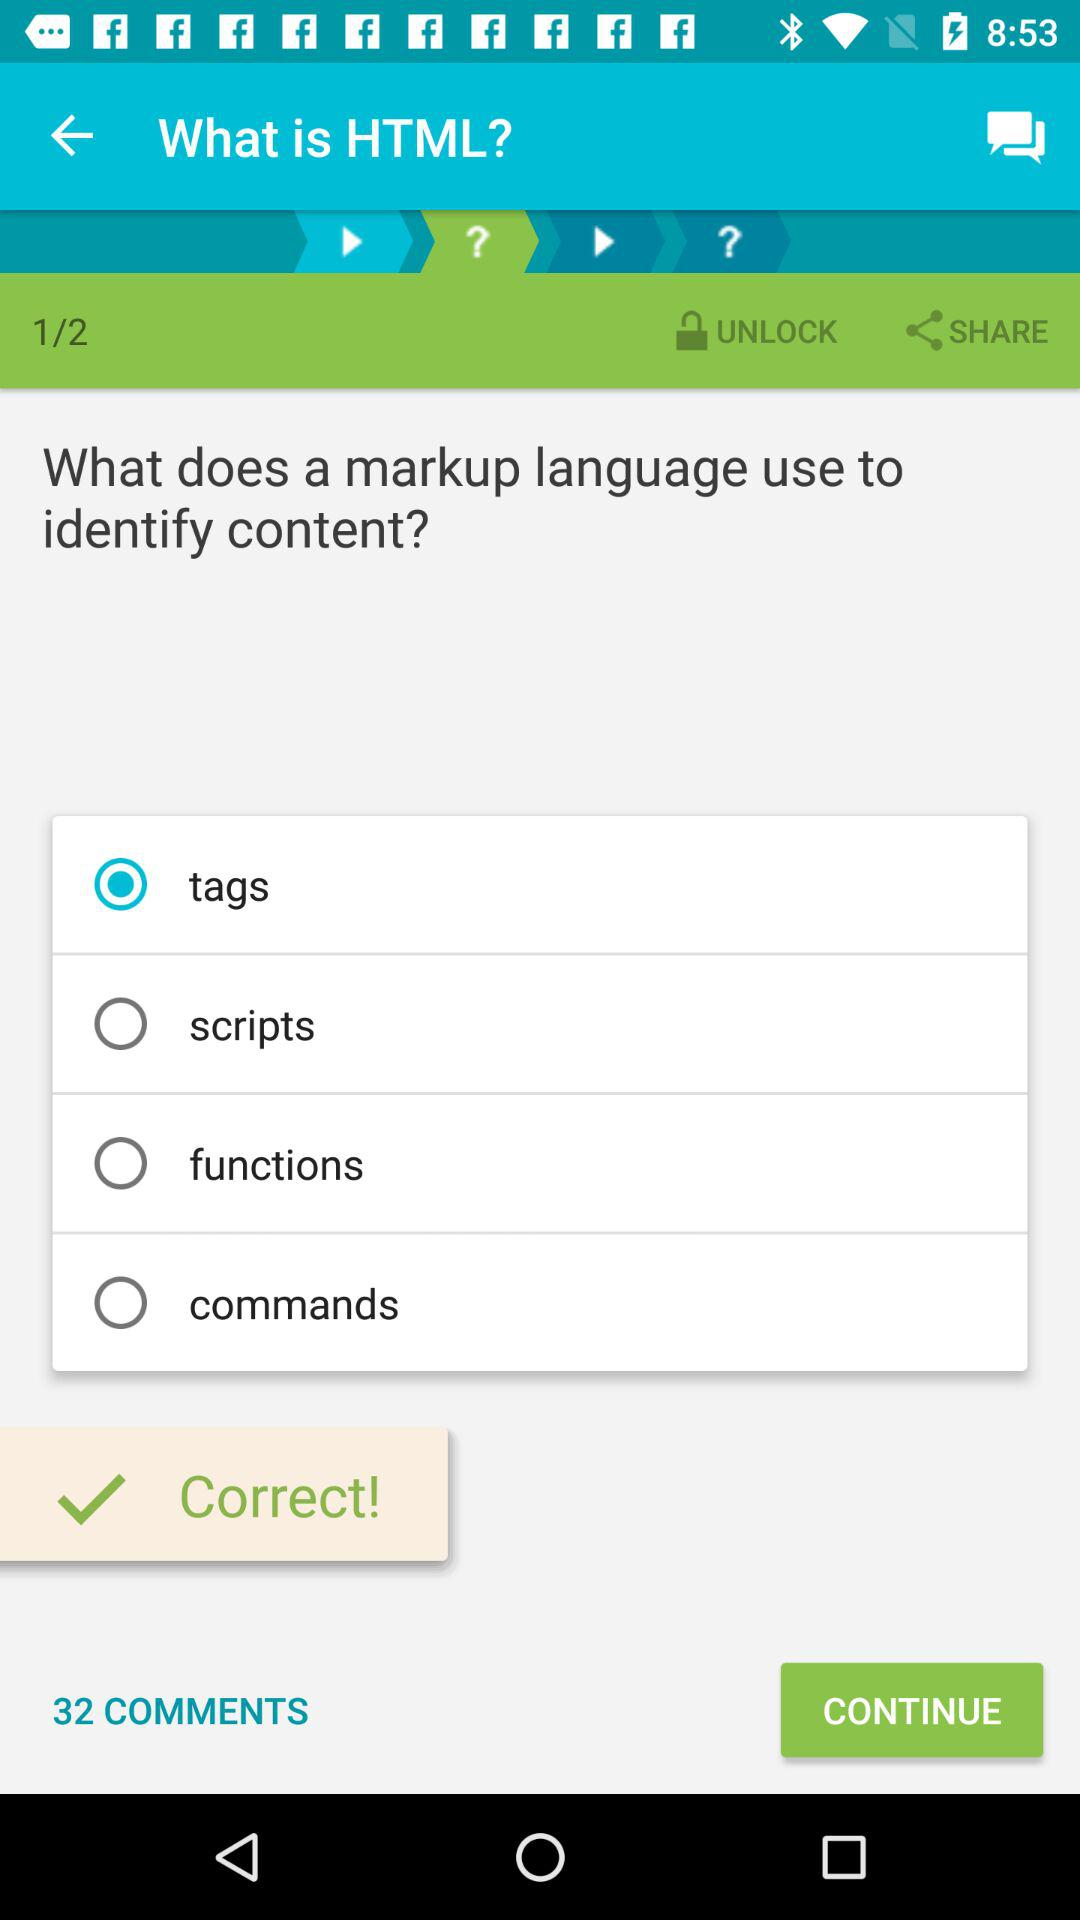What is the total number of questions on the screen? The total number of questions is 2. 